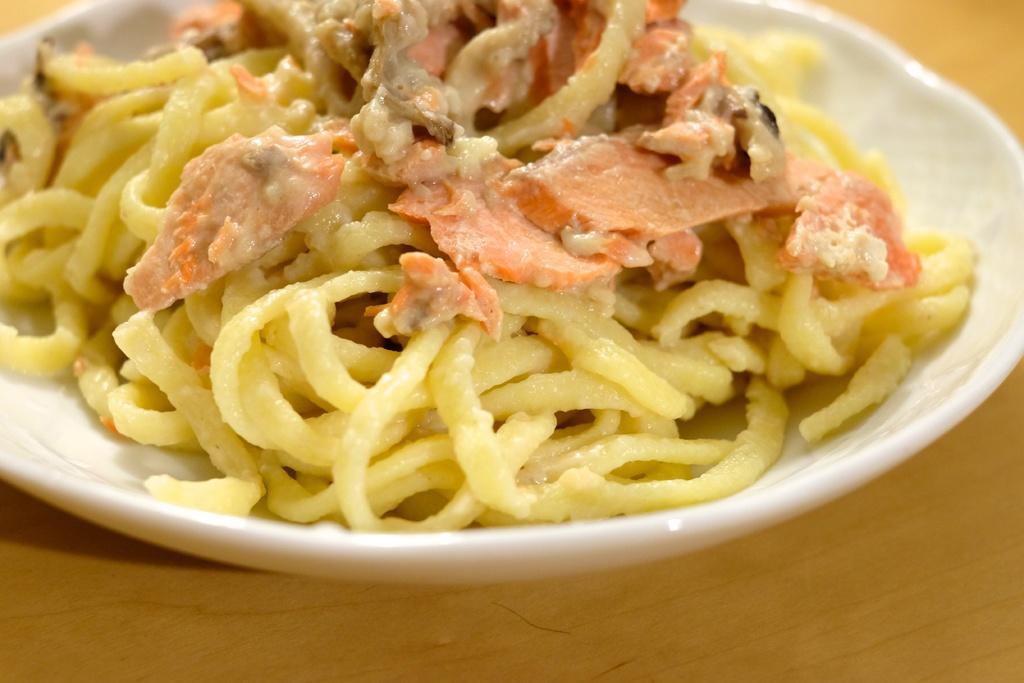Describe this image in one or two sentences. In this image, we can see food on the plate, which is placed on the table. 